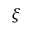Convert formula to latex. <formula><loc_0><loc_0><loc_500><loc_500>\xi</formula> 